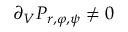Convert formula to latex. <formula><loc_0><loc_0><loc_500><loc_500>\partial _ { V } P _ { r , \varphi , \psi } \neq 0</formula> 